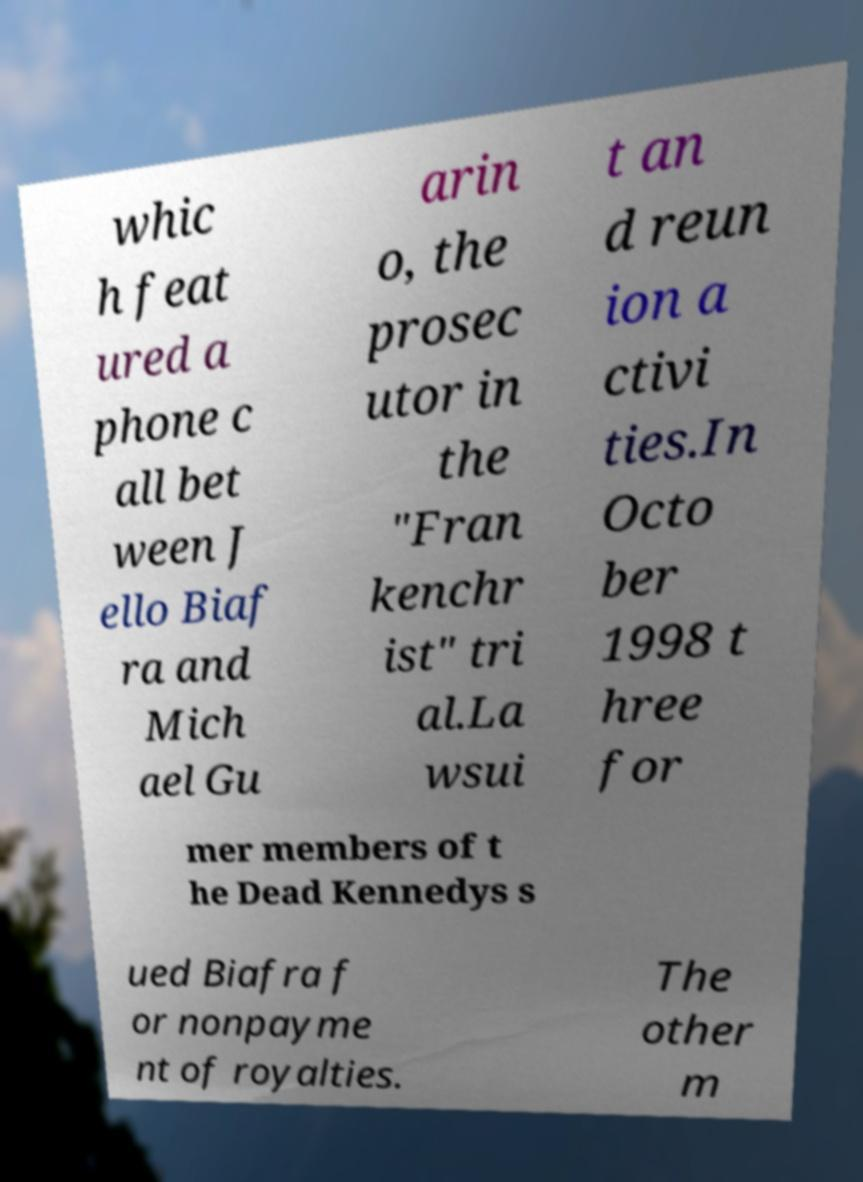I need the written content from this picture converted into text. Can you do that? whic h feat ured a phone c all bet ween J ello Biaf ra and Mich ael Gu arin o, the prosec utor in the "Fran kenchr ist" tri al.La wsui t an d reun ion a ctivi ties.In Octo ber 1998 t hree for mer members of t he Dead Kennedys s ued Biafra f or nonpayme nt of royalties. The other m 